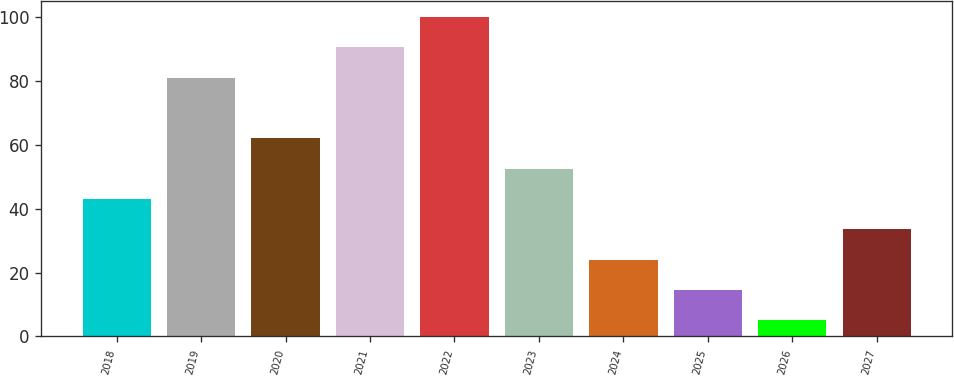<chart> <loc_0><loc_0><loc_500><loc_500><bar_chart><fcel>2018<fcel>2019<fcel>2020<fcel>2021<fcel>2022<fcel>2023<fcel>2024<fcel>2025<fcel>2026<fcel>2027<nl><fcel>43<fcel>81<fcel>62<fcel>90.5<fcel>100<fcel>52.5<fcel>24<fcel>14.5<fcel>5<fcel>33.5<nl></chart> 